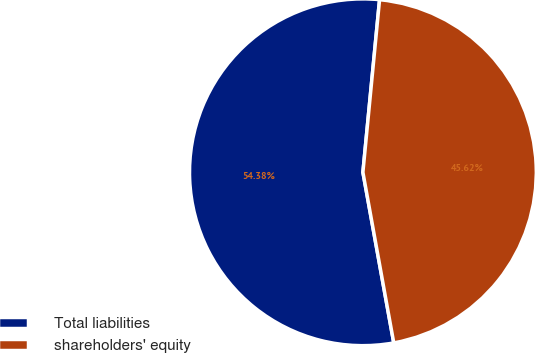Convert chart to OTSL. <chart><loc_0><loc_0><loc_500><loc_500><pie_chart><fcel>Total liabilities<fcel>shareholders' equity<nl><fcel>54.38%<fcel>45.62%<nl></chart> 